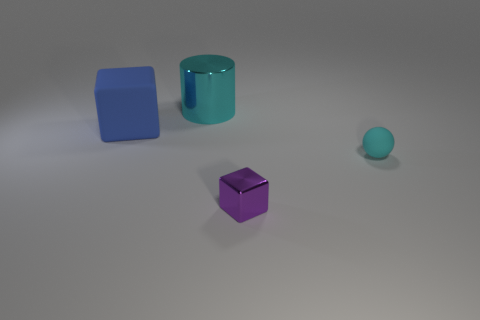If this image were part of an advertisement, what product do you think it might be promoting? If this image were part of an advertisement, the clean and simplistic nature of the scene could be promoting a modern lifestyle product, perhaps something related to home decor or organization. It could also be an ad for a graphic design software or a 3D modeling program, showcasing the ability to render realistic shapes and textures. 